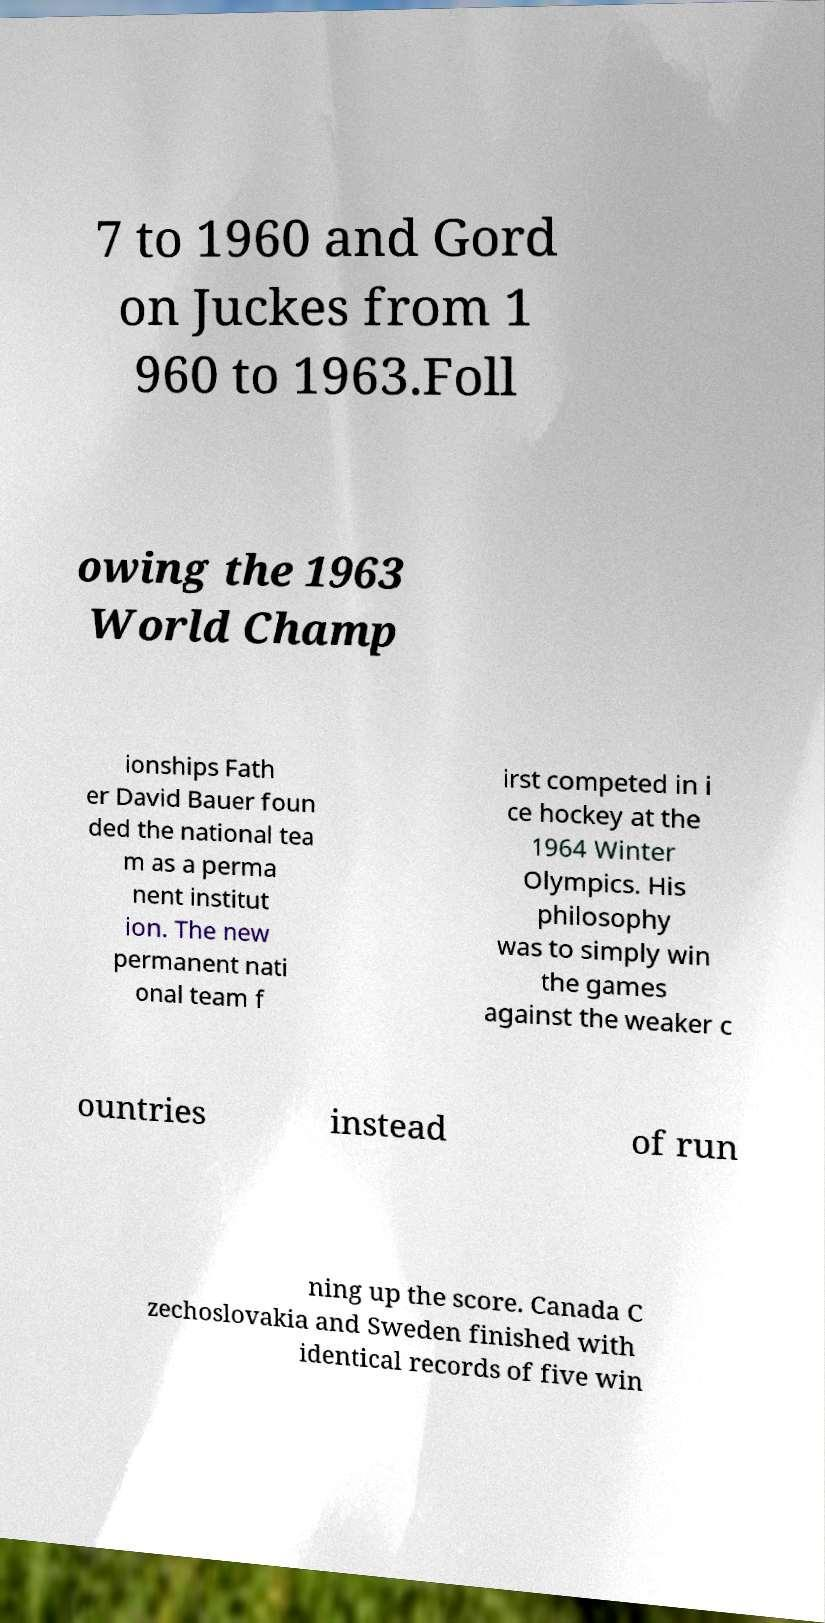Could you assist in decoding the text presented in this image and type it out clearly? 7 to 1960 and Gord on Juckes from 1 960 to 1963.Foll owing the 1963 World Champ ionships Fath er David Bauer foun ded the national tea m as a perma nent institut ion. The new permanent nati onal team f irst competed in i ce hockey at the 1964 Winter Olympics. His philosophy was to simply win the games against the weaker c ountries instead of run ning up the score. Canada C zechoslovakia and Sweden finished with identical records of five win 